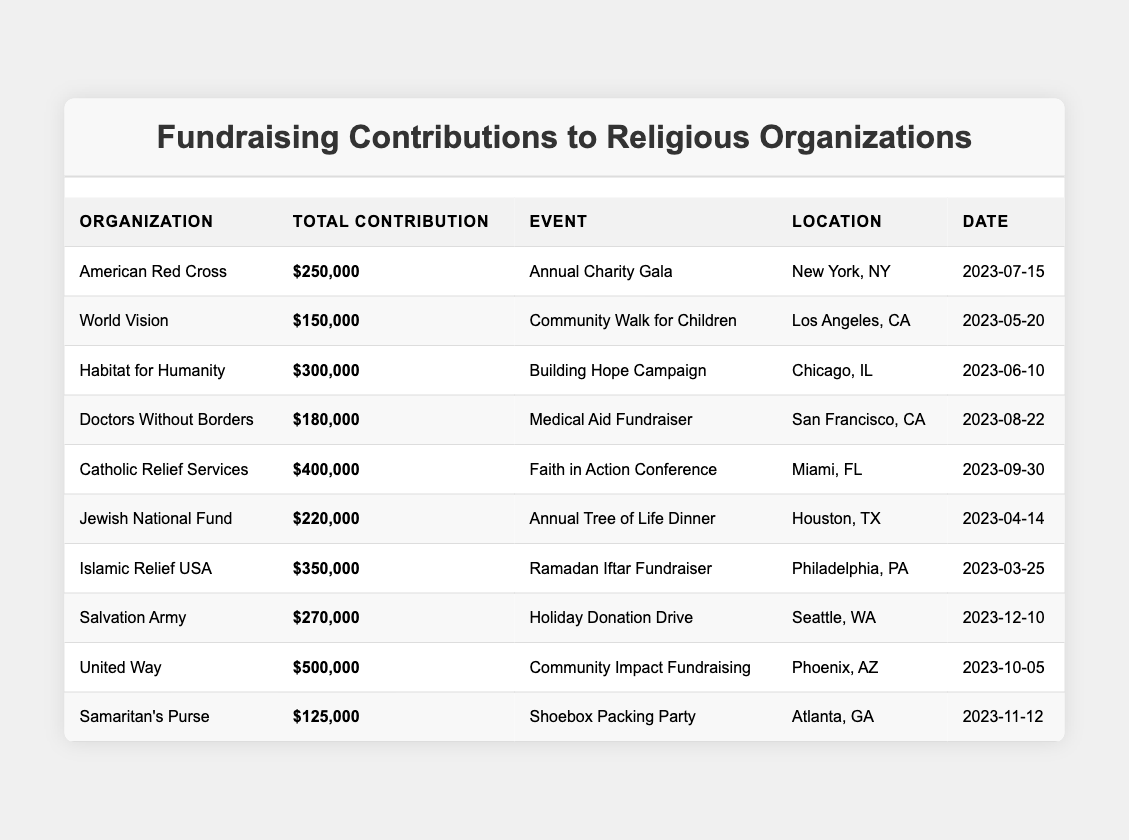What is the total contribution made by the Catholic Relief Services? The table shows that the total contribution for Catholic Relief Services is listed as $400,000.
Answer: $400,000 Which organization had the event titled "Building Hope Campaign"? From the table, Habitat for Humanity is associated with the event "Building Hope Campaign."
Answer: Habitat for Humanity What was the location of the "Community Walk for Children"? According to the table, the location for this event is Los Angeles, CA.
Answer: Los Angeles, CA Who had the highest total contribution, and what was that amount? Analyzing the contributions, United Way had the highest total contribution at $500,000.
Answer: United Way, $500,000 What event took place in Chicago, IL? The event "Building Hope Campaign" took place in Chicago, IL as per the table.
Answer: Building Hope Campaign Calculate the average total contribution from all organizations listed. There are 10 organizations. Their total contributions sum up to $2,485,000 (250,000 + 150,000 + 300,000 + 180,000 + 400,000 + 220,000 + 350,000 + 270,000 + 500,000 + 125,000). Dividing this by 10 gives an average of $248,500.
Answer: $248,500 Did the Salvation Army have a higher contribution than Doctors Without Borders? The total contribution for Salvation Army is $270,000 while Doctors Without Borders is $180,000. Since $270,000 is greater than $180,000, the answer is yes.
Answer: Yes What is the contribution difference between Habitat for Humanity and Islamic Relief USA? Habitat for Humanity contributed $300,000 while Islamic Relief USA contributed $350,000. The difference is $350,000 - $300,000 = $50,000.
Answer: $50,000 Which organization's fundraisers took place in the first half of the year? Referring to the dates, World Vision, Habitat for Humanity, and Islamic Relief USA hosted fundraisers between January and June, specifically in May, June, and March respectively.
Answer: World Vision, Habitat for Humanity, Islamic Relief USA How many organizations had total contributions of $200,000 or more? By examining the contributions, six organizations (Habitat for Humanity, Catholic Relief Services, Islamic Relief USA, Salvation Army, United Way, and Jewish National Fund) had total contributions of $200,000 or more.
Answer: Six organizations 